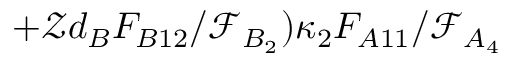<formula> <loc_0><loc_0><loc_500><loc_500>+ \mathcal { Z } d _ { B } F _ { B 1 2 } / \mathcal { F } _ { B _ { 2 } } ) \kappa _ { 2 } F _ { A 1 1 } / \mathcal { F } _ { A _ { 4 } }</formula> 